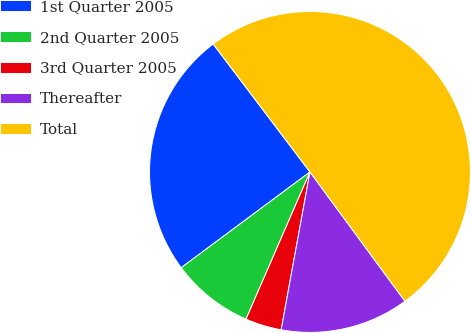Convert chart. <chart><loc_0><loc_0><loc_500><loc_500><pie_chart><fcel>1st Quarter 2005<fcel>2nd Quarter 2005<fcel>3rd Quarter 2005<fcel>Thereafter<fcel>Total<nl><fcel>24.87%<fcel>8.3%<fcel>3.65%<fcel>12.96%<fcel>50.22%<nl></chart> 